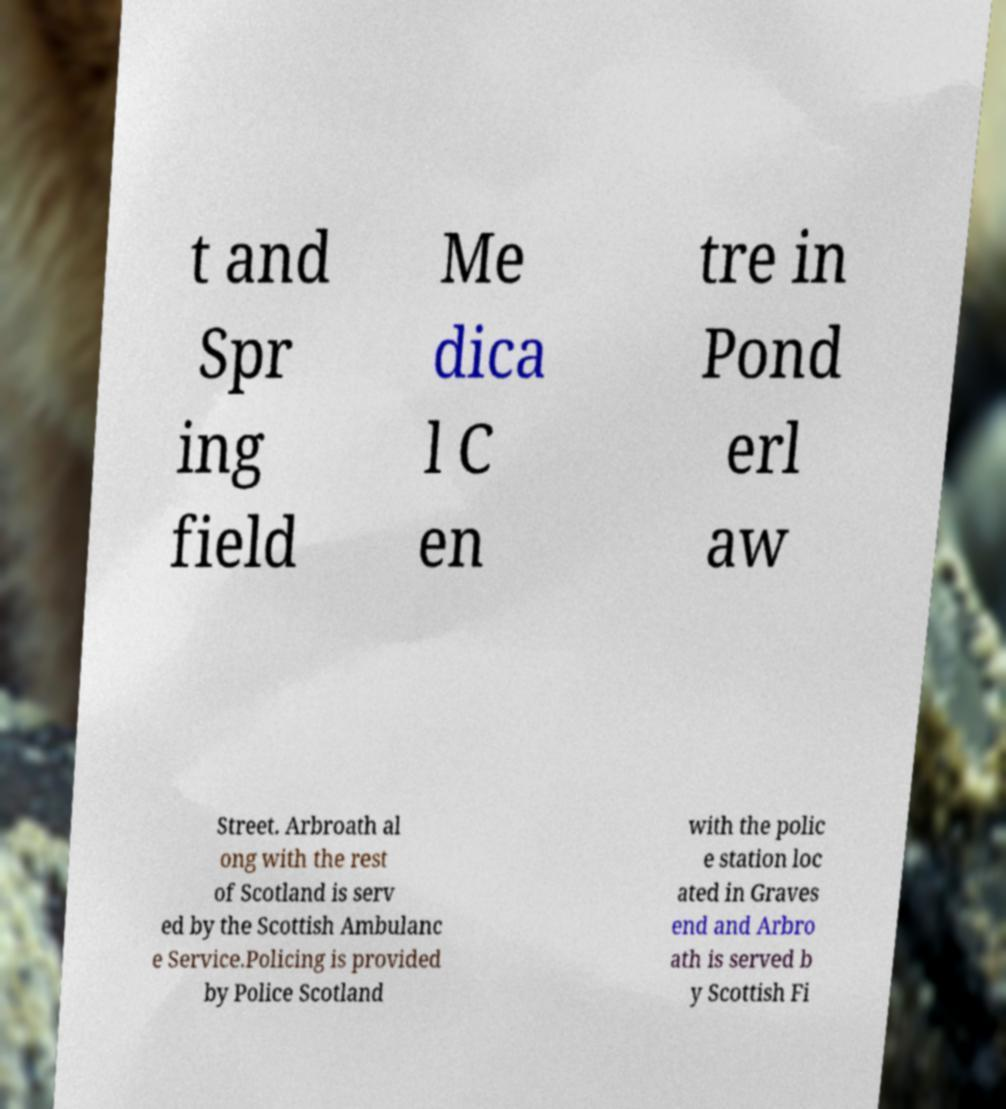Could you assist in decoding the text presented in this image and type it out clearly? t and Spr ing field Me dica l C en tre in Pond erl aw Street. Arbroath al ong with the rest of Scotland is serv ed by the Scottish Ambulanc e Service.Policing is provided by Police Scotland with the polic e station loc ated in Graves end and Arbro ath is served b y Scottish Fi 